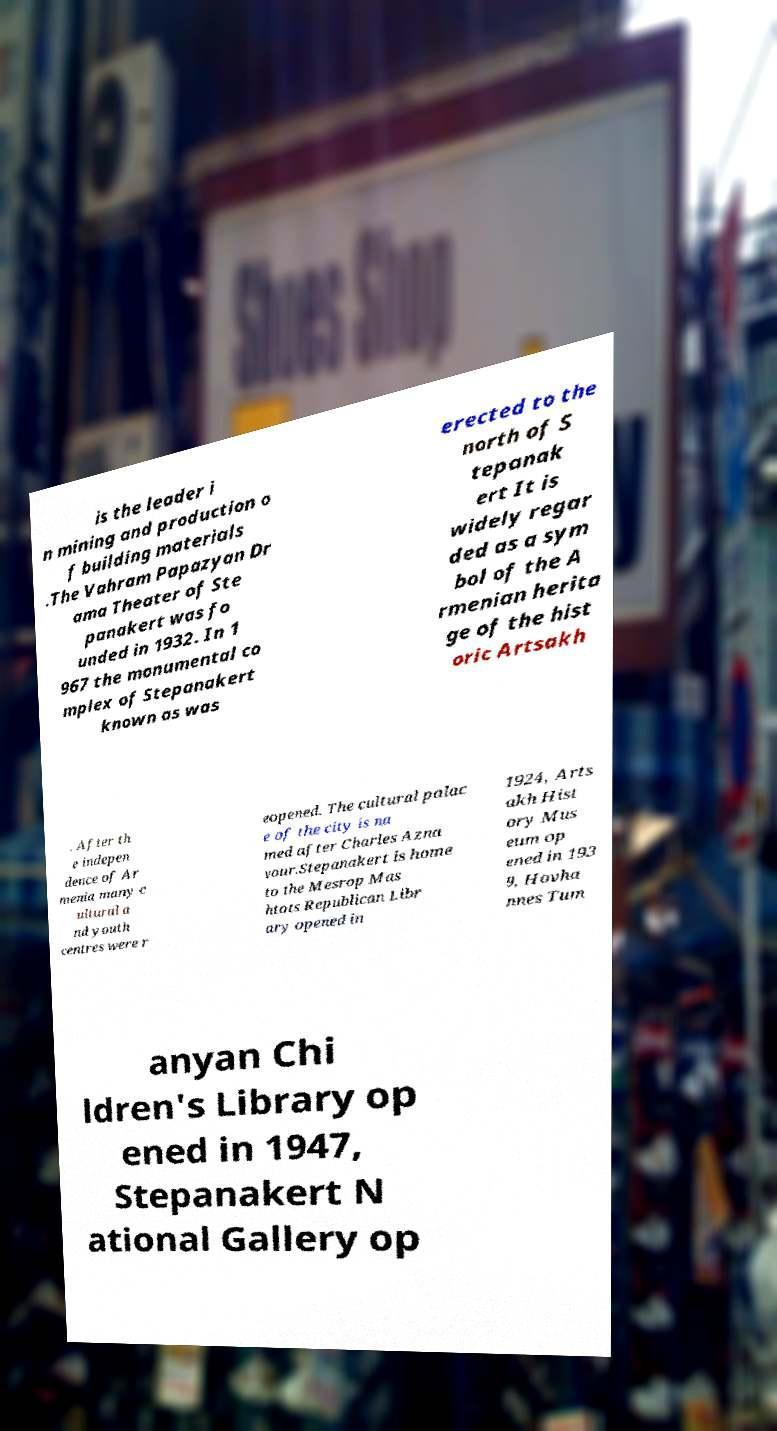What messages or text are displayed in this image? I need them in a readable, typed format. is the leader i n mining and production o f building materials .The Vahram Papazyan Dr ama Theater of Ste panakert was fo unded in 1932. In 1 967 the monumental co mplex of Stepanakert known as was erected to the north of S tepanak ert It is widely regar ded as a sym bol of the A rmenian herita ge of the hist oric Artsakh . After th e indepen dence of Ar menia many c ultural a nd youth centres were r eopened. The cultural palac e of the city is na med after Charles Azna vour.Stepanakert is home to the Mesrop Mas htots Republican Libr ary opened in 1924, Arts akh Hist ory Mus eum op ened in 193 9, Hovha nnes Tum anyan Chi ldren's Library op ened in 1947, Stepanakert N ational Gallery op 